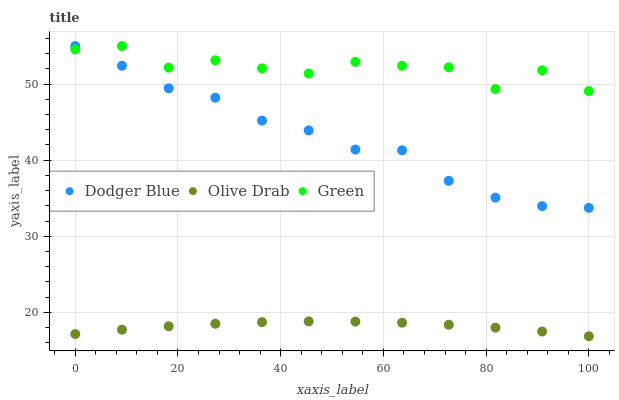Does Olive Drab have the minimum area under the curve?
Answer yes or no. Yes. Does Green have the maximum area under the curve?
Answer yes or no. Yes. Does Dodger Blue have the minimum area under the curve?
Answer yes or no. No. Does Dodger Blue have the maximum area under the curve?
Answer yes or no. No. Is Olive Drab the smoothest?
Answer yes or no. Yes. Is Green the roughest?
Answer yes or no. Yes. Is Dodger Blue the smoothest?
Answer yes or no. No. Is Dodger Blue the roughest?
Answer yes or no. No. Does Olive Drab have the lowest value?
Answer yes or no. Yes. Does Dodger Blue have the lowest value?
Answer yes or no. No. Does Dodger Blue have the highest value?
Answer yes or no. Yes. Does Olive Drab have the highest value?
Answer yes or no. No. Is Olive Drab less than Dodger Blue?
Answer yes or no. Yes. Is Green greater than Olive Drab?
Answer yes or no. Yes. Does Dodger Blue intersect Green?
Answer yes or no. Yes. Is Dodger Blue less than Green?
Answer yes or no. No. Is Dodger Blue greater than Green?
Answer yes or no. No. Does Olive Drab intersect Dodger Blue?
Answer yes or no. No. 